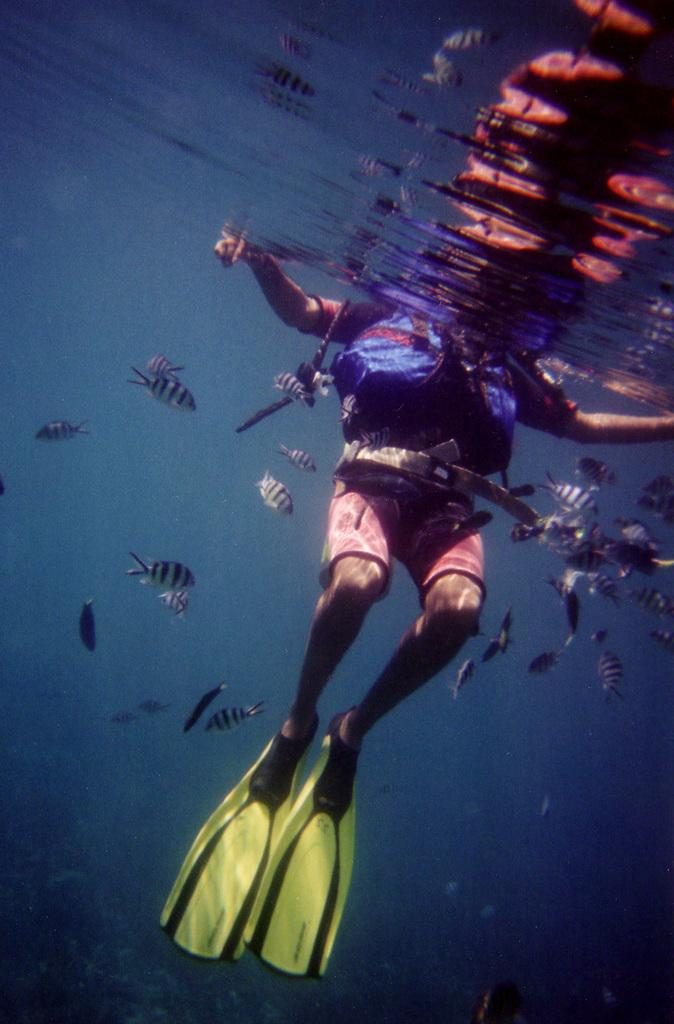What is the person in the image doing? There is a person swimming in the water in the image. What type of footwear is the person wearing? The person is wearing swim shoes. Can you identify any other objects in the image? Yes, there is a bag visible in the image. What else can be seen in the water besides the person swimming? There are fishes in the water. What date is circled on the calendar in the image? There is no calendar present in the image. Can you describe the playground equipment visible in the image? There is no playground equipment visible in the image; it features a person swimming in the water with fishes. 